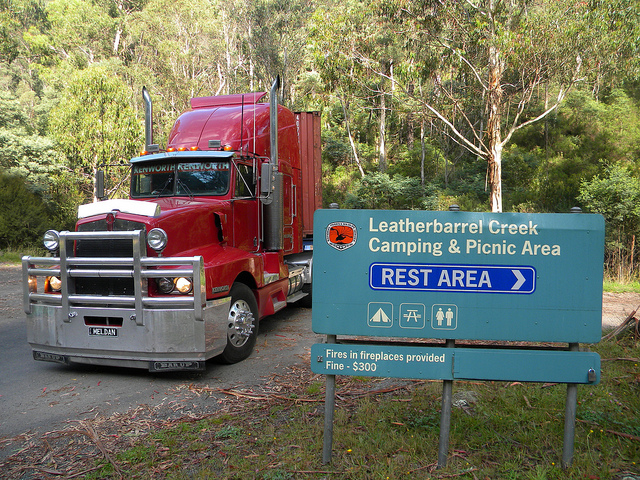Identify and read out the text in this image. Leatherbarrel Creek Camping &amp; Picnic Area AREA REST $300 Fine provided fireplaces in Fires 